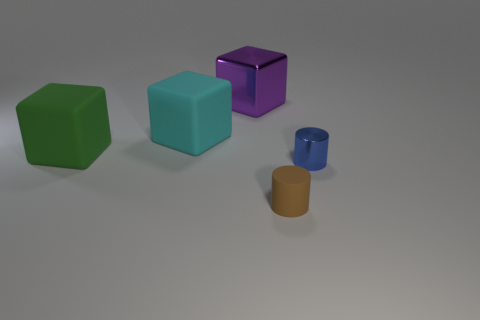Subtract all big cyan matte cubes. How many cubes are left? 2 Subtract all cyan blocks. How many blocks are left? 2 Add 3 big rubber blocks. How many objects exist? 8 Subtract all cylinders. How many objects are left? 3 Add 1 tiny rubber cylinders. How many tiny rubber cylinders are left? 2 Add 2 green metallic spheres. How many green metallic spheres exist? 2 Subtract 0 brown blocks. How many objects are left? 5 Subtract 2 cylinders. How many cylinders are left? 0 Subtract all brown blocks. Subtract all gray spheres. How many blocks are left? 3 Subtract all blue blocks. How many brown cylinders are left? 1 